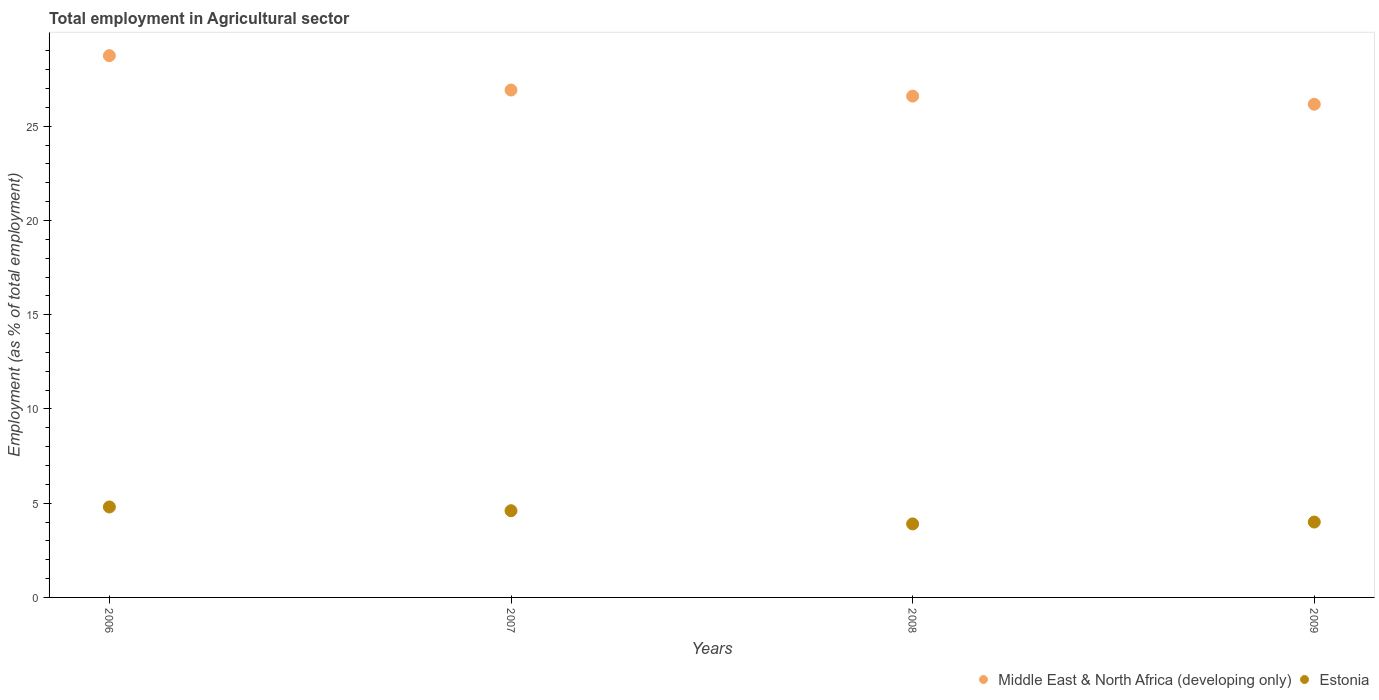What is the employment in agricultural sector in Middle East & North Africa (developing only) in 2009?
Offer a very short reply. 26.16. Across all years, what is the maximum employment in agricultural sector in Middle East & North Africa (developing only)?
Give a very brief answer. 28.74. Across all years, what is the minimum employment in agricultural sector in Middle East & North Africa (developing only)?
Provide a succinct answer. 26.16. What is the total employment in agricultural sector in Estonia in the graph?
Offer a very short reply. 17.3. What is the difference between the employment in agricultural sector in Estonia in 2007 and that in 2008?
Your answer should be very brief. 0.7. What is the difference between the employment in agricultural sector in Estonia in 2006 and the employment in agricultural sector in Middle East & North Africa (developing only) in 2009?
Give a very brief answer. -21.36. What is the average employment in agricultural sector in Middle East & North Africa (developing only) per year?
Keep it short and to the point. 27.11. In the year 2008, what is the difference between the employment in agricultural sector in Estonia and employment in agricultural sector in Middle East & North Africa (developing only)?
Provide a short and direct response. -22.7. In how many years, is the employment in agricultural sector in Middle East & North Africa (developing only) greater than 3 %?
Your answer should be compact. 4. What is the ratio of the employment in agricultural sector in Middle East & North Africa (developing only) in 2006 to that in 2007?
Provide a short and direct response. 1.07. Is the employment in agricultural sector in Middle East & North Africa (developing only) in 2008 less than that in 2009?
Offer a terse response. No. What is the difference between the highest and the second highest employment in agricultural sector in Estonia?
Provide a succinct answer. 0.2. What is the difference between the highest and the lowest employment in agricultural sector in Middle East & North Africa (developing only)?
Ensure brevity in your answer.  2.58. Is the employment in agricultural sector in Estonia strictly greater than the employment in agricultural sector in Middle East & North Africa (developing only) over the years?
Your answer should be compact. No. Is the employment in agricultural sector in Estonia strictly less than the employment in agricultural sector in Middle East & North Africa (developing only) over the years?
Your answer should be very brief. Yes. How many years are there in the graph?
Provide a short and direct response. 4. Does the graph contain any zero values?
Your answer should be compact. No. How many legend labels are there?
Ensure brevity in your answer.  2. What is the title of the graph?
Keep it short and to the point. Total employment in Agricultural sector. Does "Zambia" appear as one of the legend labels in the graph?
Your response must be concise. No. What is the label or title of the X-axis?
Make the answer very short. Years. What is the label or title of the Y-axis?
Give a very brief answer. Employment (as % of total employment). What is the Employment (as % of total employment) of Middle East & North Africa (developing only) in 2006?
Your answer should be compact. 28.74. What is the Employment (as % of total employment) in Estonia in 2006?
Provide a short and direct response. 4.8. What is the Employment (as % of total employment) in Middle East & North Africa (developing only) in 2007?
Make the answer very short. 26.92. What is the Employment (as % of total employment) of Estonia in 2007?
Ensure brevity in your answer.  4.6. What is the Employment (as % of total employment) in Middle East & North Africa (developing only) in 2008?
Offer a terse response. 26.6. What is the Employment (as % of total employment) of Estonia in 2008?
Offer a very short reply. 3.9. What is the Employment (as % of total employment) of Middle East & North Africa (developing only) in 2009?
Offer a terse response. 26.16. What is the Employment (as % of total employment) of Estonia in 2009?
Your answer should be very brief. 4. Across all years, what is the maximum Employment (as % of total employment) of Middle East & North Africa (developing only)?
Your answer should be very brief. 28.74. Across all years, what is the maximum Employment (as % of total employment) in Estonia?
Make the answer very short. 4.8. Across all years, what is the minimum Employment (as % of total employment) of Middle East & North Africa (developing only)?
Offer a terse response. 26.16. Across all years, what is the minimum Employment (as % of total employment) of Estonia?
Make the answer very short. 3.9. What is the total Employment (as % of total employment) of Middle East & North Africa (developing only) in the graph?
Ensure brevity in your answer.  108.42. What is the difference between the Employment (as % of total employment) in Middle East & North Africa (developing only) in 2006 and that in 2007?
Your answer should be compact. 1.82. What is the difference between the Employment (as % of total employment) of Middle East & North Africa (developing only) in 2006 and that in 2008?
Keep it short and to the point. 2.15. What is the difference between the Employment (as % of total employment) in Middle East & North Africa (developing only) in 2006 and that in 2009?
Offer a very short reply. 2.58. What is the difference between the Employment (as % of total employment) of Estonia in 2006 and that in 2009?
Make the answer very short. 0.8. What is the difference between the Employment (as % of total employment) of Middle East & North Africa (developing only) in 2007 and that in 2008?
Your answer should be very brief. 0.32. What is the difference between the Employment (as % of total employment) of Middle East & North Africa (developing only) in 2007 and that in 2009?
Keep it short and to the point. 0.75. What is the difference between the Employment (as % of total employment) in Estonia in 2007 and that in 2009?
Provide a succinct answer. 0.6. What is the difference between the Employment (as % of total employment) of Middle East & North Africa (developing only) in 2008 and that in 2009?
Provide a short and direct response. 0.43. What is the difference between the Employment (as % of total employment) in Middle East & North Africa (developing only) in 2006 and the Employment (as % of total employment) in Estonia in 2007?
Your response must be concise. 24.14. What is the difference between the Employment (as % of total employment) of Middle East & North Africa (developing only) in 2006 and the Employment (as % of total employment) of Estonia in 2008?
Your answer should be compact. 24.84. What is the difference between the Employment (as % of total employment) in Middle East & North Africa (developing only) in 2006 and the Employment (as % of total employment) in Estonia in 2009?
Offer a very short reply. 24.74. What is the difference between the Employment (as % of total employment) in Middle East & North Africa (developing only) in 2007 and the Employment (as % of total employment) in Estonia in 2008?
Keep it short and to the point. 23.02. What is the difference between the Employment (as % of total employment) of Middle East & North Africa (developing only) in 2007 and the Employment (as % of total employment) of Estonia in 2009?
Your answer should be very brief. 22.92. What is the difference between the Employment (as % of total employment) of Middle East & North Africa (developing only) in 2008 and the Employment (as % of total employment) of Estonia in 2009?
Keep it short and to the point. 22.6. What is the average Employment (as % of total employment) of Middle East & North Africa (developing only) per year?
Offer a very short reply. 27.11. What is the average Employment (as % of total employment) in Estonia per year?
Your answer should be compact. 4.33. In the year 2006, what is the difference between the Employment (as % of total employment) of Middle East & North Africa (developing only) and Employment (as % of total employment) of Estonia?
Make the answer very short. 23.94. In the year 2007, what is the difference between the Employment (as % of total employment) of Middle East & North Africa (developing only) and Employment (as % of total employment) of Estonia?
Your response must be concise. 22.32. In the year 2008, what is the difference between the Employment (as % of total employment) of Middle East & North Africa (developing only) and Employment (as % of total employment) of Estonia?
Offer a terse response. 22.7. In the year 2009, what is the difference between the Employment (as % of total employment) of Middle East & North Africa (developing only) and Employment (as % of total employment) of Estonia?
Ensure brevity in your answer.  22.16. What is the ratio of the Employment (as % of total employment) of Middle East & North Africa (developing only) in 2006 to that in 2007?
Your answer should be very brief. 1.07. What is the ratio of the Employment (as % of total employment) of Estonia in 2006 to that in 2007?
Offer a very short reply. 1.04. What is the ratio of the Employment (as % of total employment) in Middle East & North Africa (developing only) in 2006 to that in 2008?
Keep it short and to the point. 1.08. What is the ratio of the Employment (as % of total employment) in Estonia in 2006 to that in 2008?
Provide a short and direct response. 1.23. What is the ratio of the Employment (as % of total employment) in Middle East & North Africa (developing only) in 2006 to that in 2009?
Offer a terse response. 1.1. What is the ratio of the Employment (as % of total employment) of Middle East & North Africa (developing only) in 2007 to that in 2008?
Your answer should be very brief. 1.01. What is the ratio of the Employment (as % of total employment) in Estonia in 2007 to that in 2008?
Offer a terse response. 1.18. What is the ratio of the Employment (as % of total employment) of Middle East & North Africa (developing only) in 2007 to that in 2009?
Your response must be concise. 1.03. What is the ratio of the Employment (as % of total employment) of Estonia in 2007 to that in 2009?
Make the answer very short. 1.15. What is the ratio of the Employment (as % of total employment) in Middle East & North Africa (developing only) in 2008 to that in 2009?
Your answer should be very brief. 1.02. What is the ratio of the Employment (as % of total employment) in Estonia in 2008 to that in 2009?
Give a very brief answer. 0.97. What is the difference between the highest and the second highest Employment (as % of total employment) of Middle East & North Africa (developing only)?
Your answer should be very brief. 1.82. What is the difference between the highest and the lowest Employment (as % of total employment) in Middle East & North Africa (developing only)?
Keep it short and to the point. 2.58. 